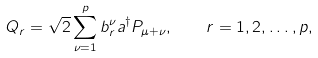<formula> <loc_0><loc_0><loc_500><loc_500>Q _ { r } = \sqrt { 2 } \sum _ { \nu = 1 } ^ { p } b _ { r } ^ { \nu } a ^ { \dagger } P _ { \mu + \nu } , \quad r = 1 , 2 , \dots , p ,</formula> 